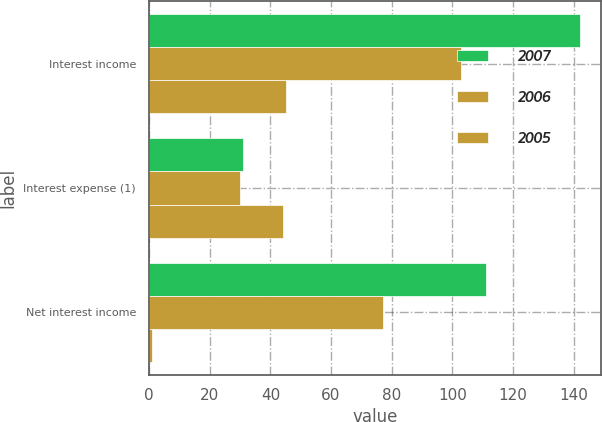<chart> <loc_0><loc_0><loc_500><loc_500><stacked_bar_chart><ecel><fcel>Interest income<fcel>Interest expense (1)<fcel>Net interest income<nl><fcel>2007<fcel>142<fcel>31<fcel>111<nl><fcel>2006<fcel>103<fcel>30<fcel>77<nl><fcel>2005<fcel>45<fcel>44<fcel>1<nl></chart> 